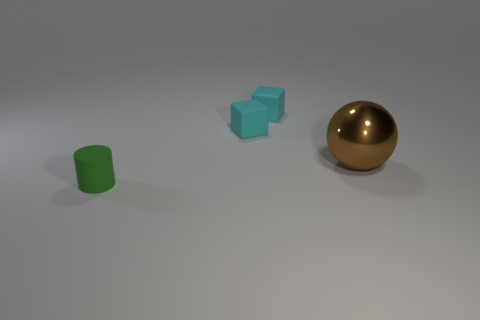Is there anything else that is made of the same material as the large object?
Provide a succinct answer. No. How many objects are right of the green object and left of the large brown object?
Offer a very short reply. 2. Is there any other thing that is the same shape as the big thing?
Your answer should be compact. No. There is a big metal sphere; is its color the same as the small thing that is in front of the metallic thing?
Keep it short and to the point. No. The matte object that is in front of the metal sphere has what shape?
Provide a short and direct response. Cylinder. What number of other objects are there of the same material as the green thing?
Offer a very short reply. 2. What is the material of the green cylinder?
Keep it short and to the point. Rubber. What number of tiny objects are either blue rubber objects or brown things?
Make the answer very short. 0. What number of big objects are behind the green rubber object?
Give a very brief answer. 1. Are there any rubber cubes that have the same color as the tiny cylinder?
Give a very brief answer. No. 